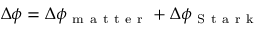Convert formula to latex. <formula><loc_0><loc_0><loc_500><loc_500>\Delta \phi = \Delta \phi _ { m a t t e r } + \Delta \phi _ { S t a r k }</formula> 